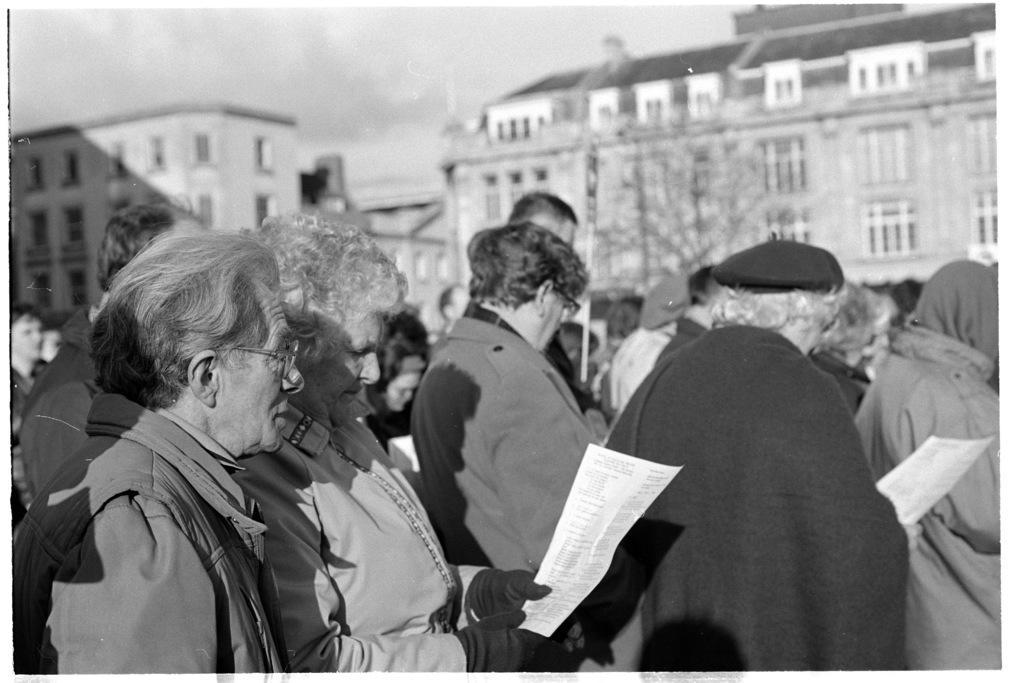Please provide a concise description of this image. In this image we can see people standing and holding a paper with written text on it, behind we can see buildings, there are few windows, at the top we can see the sky. 